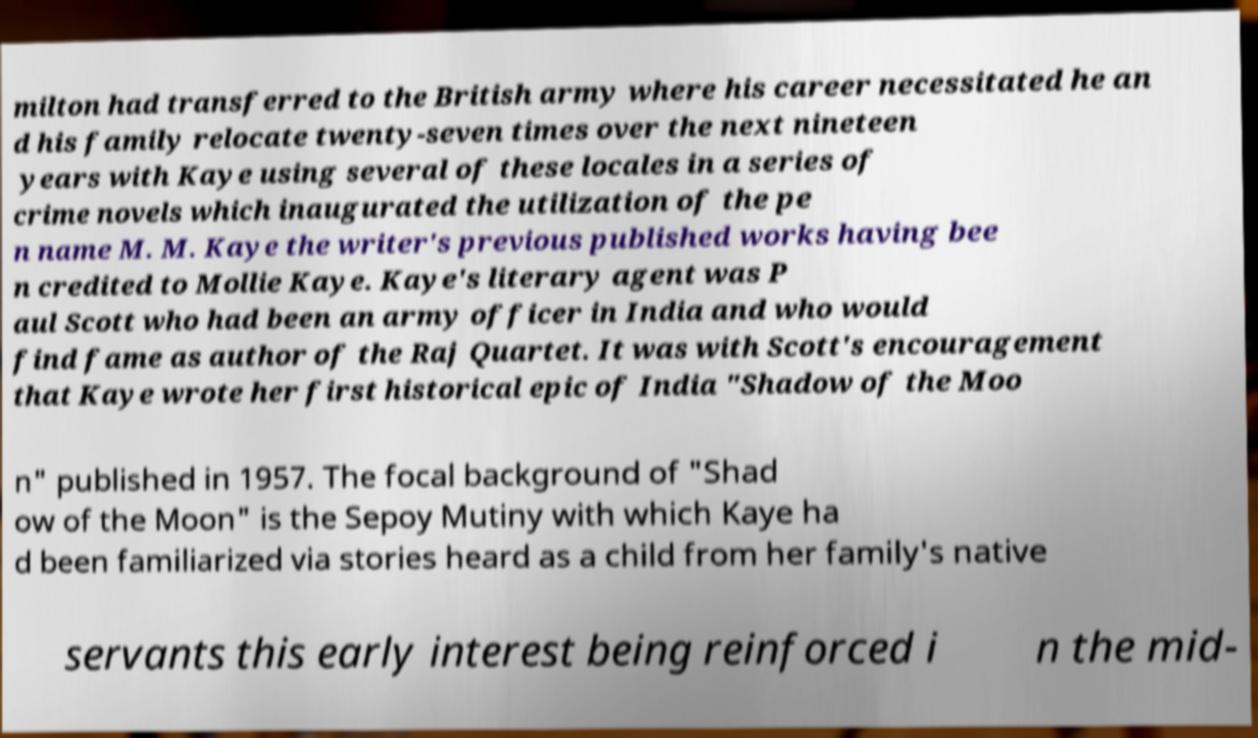What messages or text are displayed in this image? I need them in a readable, typed format. milton had transferred to the British army where his career necessitated he an d his family relocate twenty-seven times over the next nineteen years with Kaye using several of these locales in a series of crime novels which inaugurated the utilization of the pe n name M. M. Kaye the writer's previous published works having bee n credited to Mollie Kaye. Kaye's literary agent was P aul Scott who had been an army officer in India and who would find fame as author of the Raj Quartet. It was with Scott's encouragement that Kaye wrote her first historical epic of India "Shadow of the Moo n" published in 1957. The focal background of "Shad ow of the Moon" is the Sepoy Mutiny with which Kaye ha d been familiarized via stories heard as a child from her family's native servants this early interest being reinforced i n the mid- 